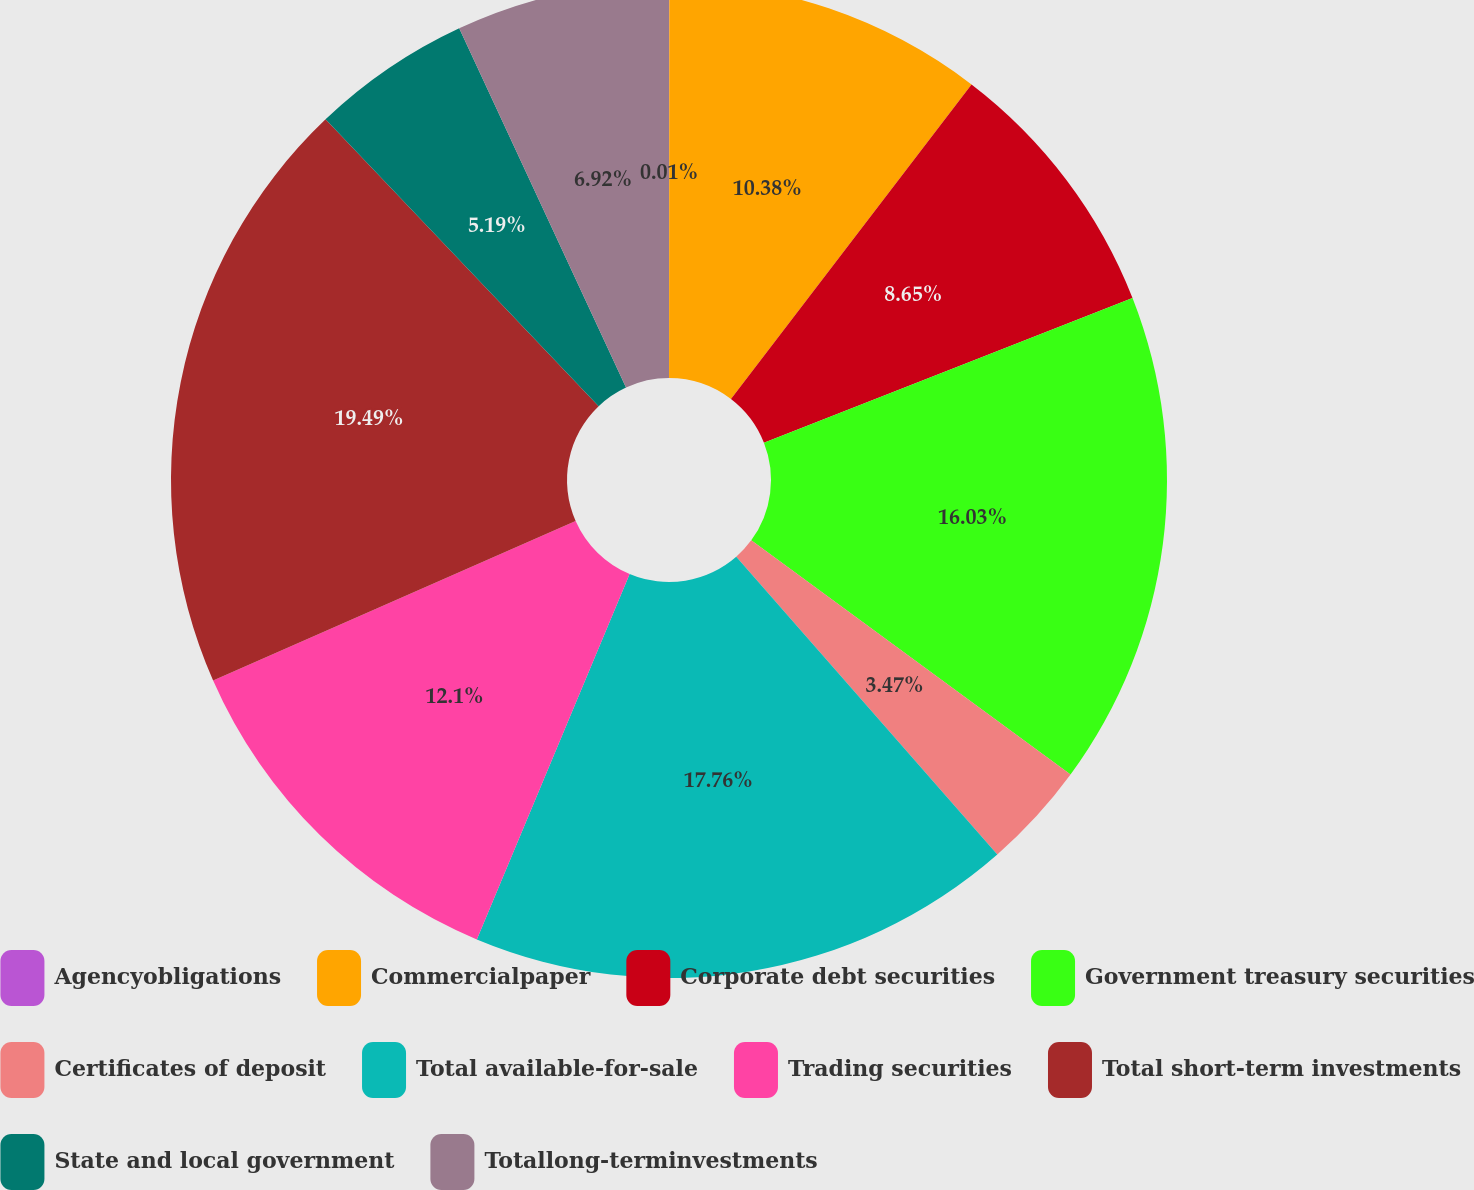Convert chart. <chart><loc_0><loc_0><loc_500><loc_500><pie_chart><fcel>Agencyobligations<fcel>Commercialpaper<fcel>Corporate debt securities<fcel>Government treasury securities<fcel>Certificates of deposit<fcel>Total available-for-sale<fcel>Trading securities<fcel>Total short-term investments<fcel>State and local government<fcel>Totallong-terminvestments<nl><fcel>0.01%<fcel>10.38%<fcel>8.65%<fcel>16.03%<fcel>3.47%<fcel>17.76%<fcel>12.1%<fcel>19.48%<fcel>5.19%<fcel>6.92%<nl></chart> 